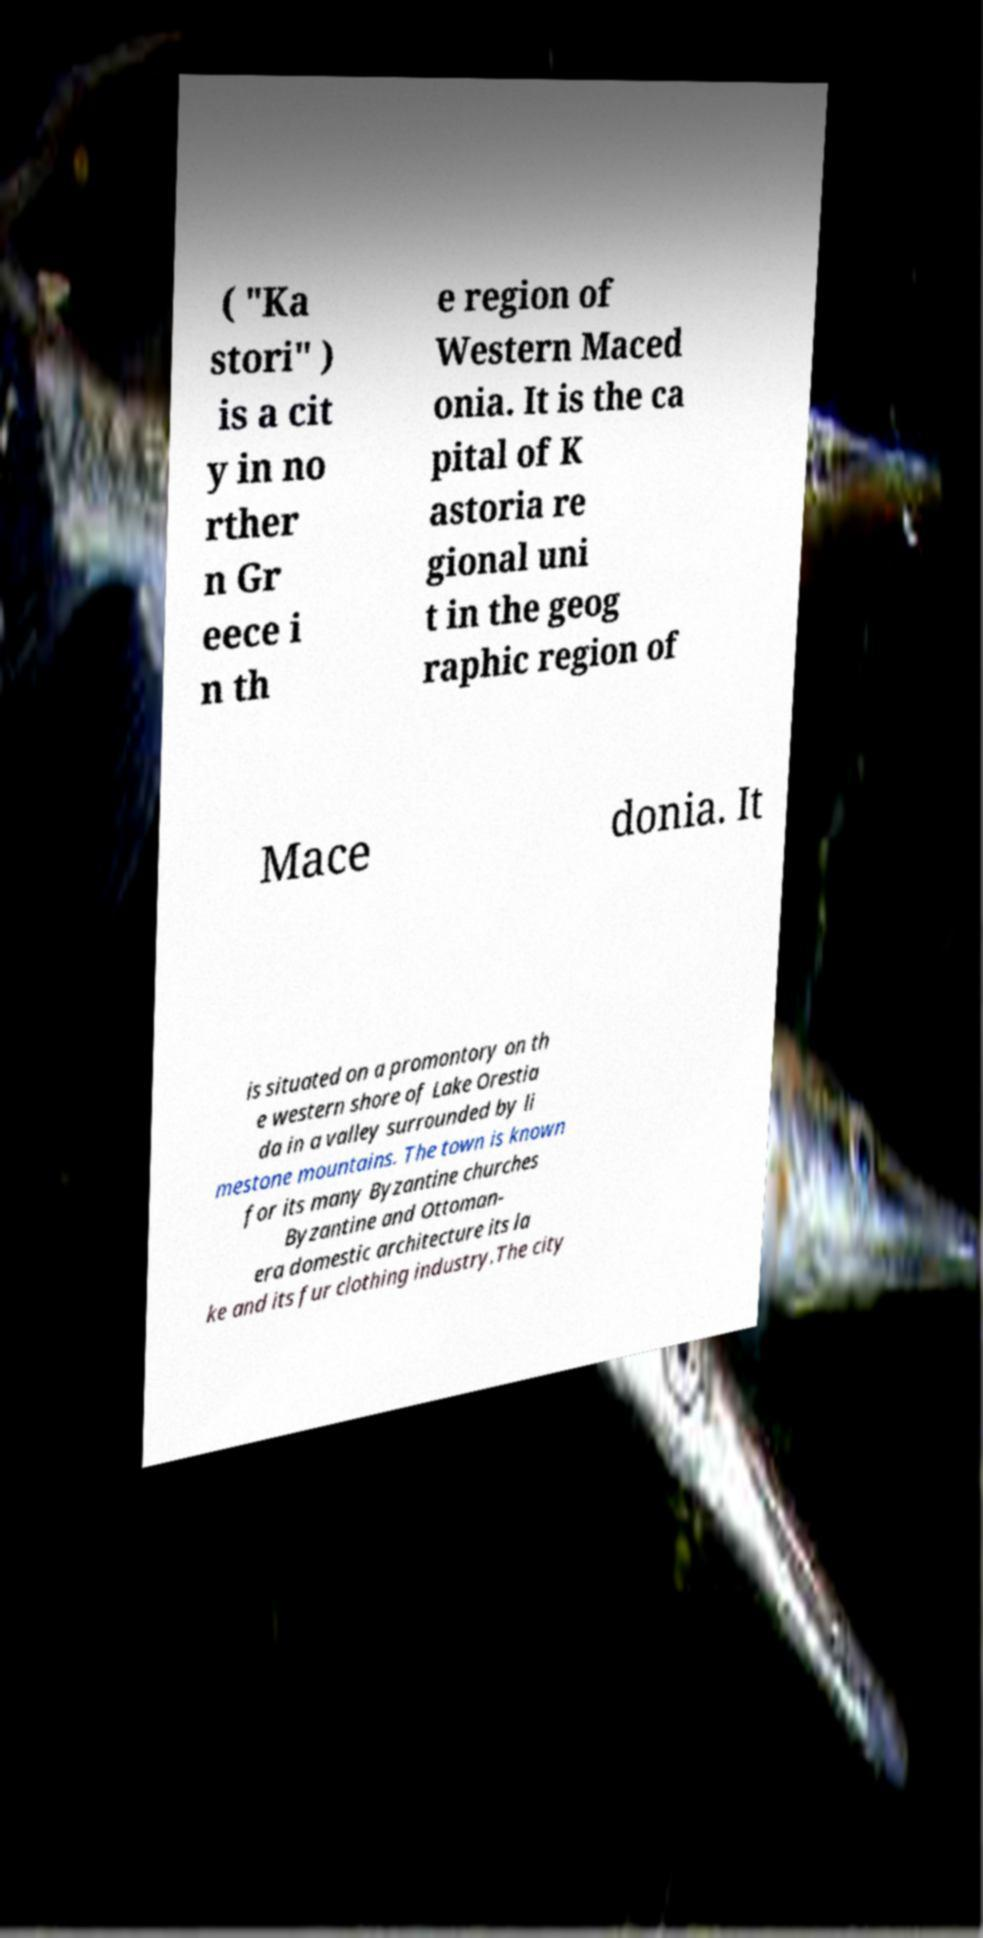Please identify and transcribe the text found in this image. ( "Ka stori" ) is a cit y in no rther n Gr eece i n th e region of Western Maced onia. It is the ca pital of K astoria re gional uni t in the geog raphic region of Mace donia. It is situated on a promontory on th e western shore of Lake Orestia da in a valley surrounded by li mestone mountains. The town is known for its many Byzantine churches Byzantine and Ottoman- era domestic architecture its la ke and its fur clothing industry.The city 